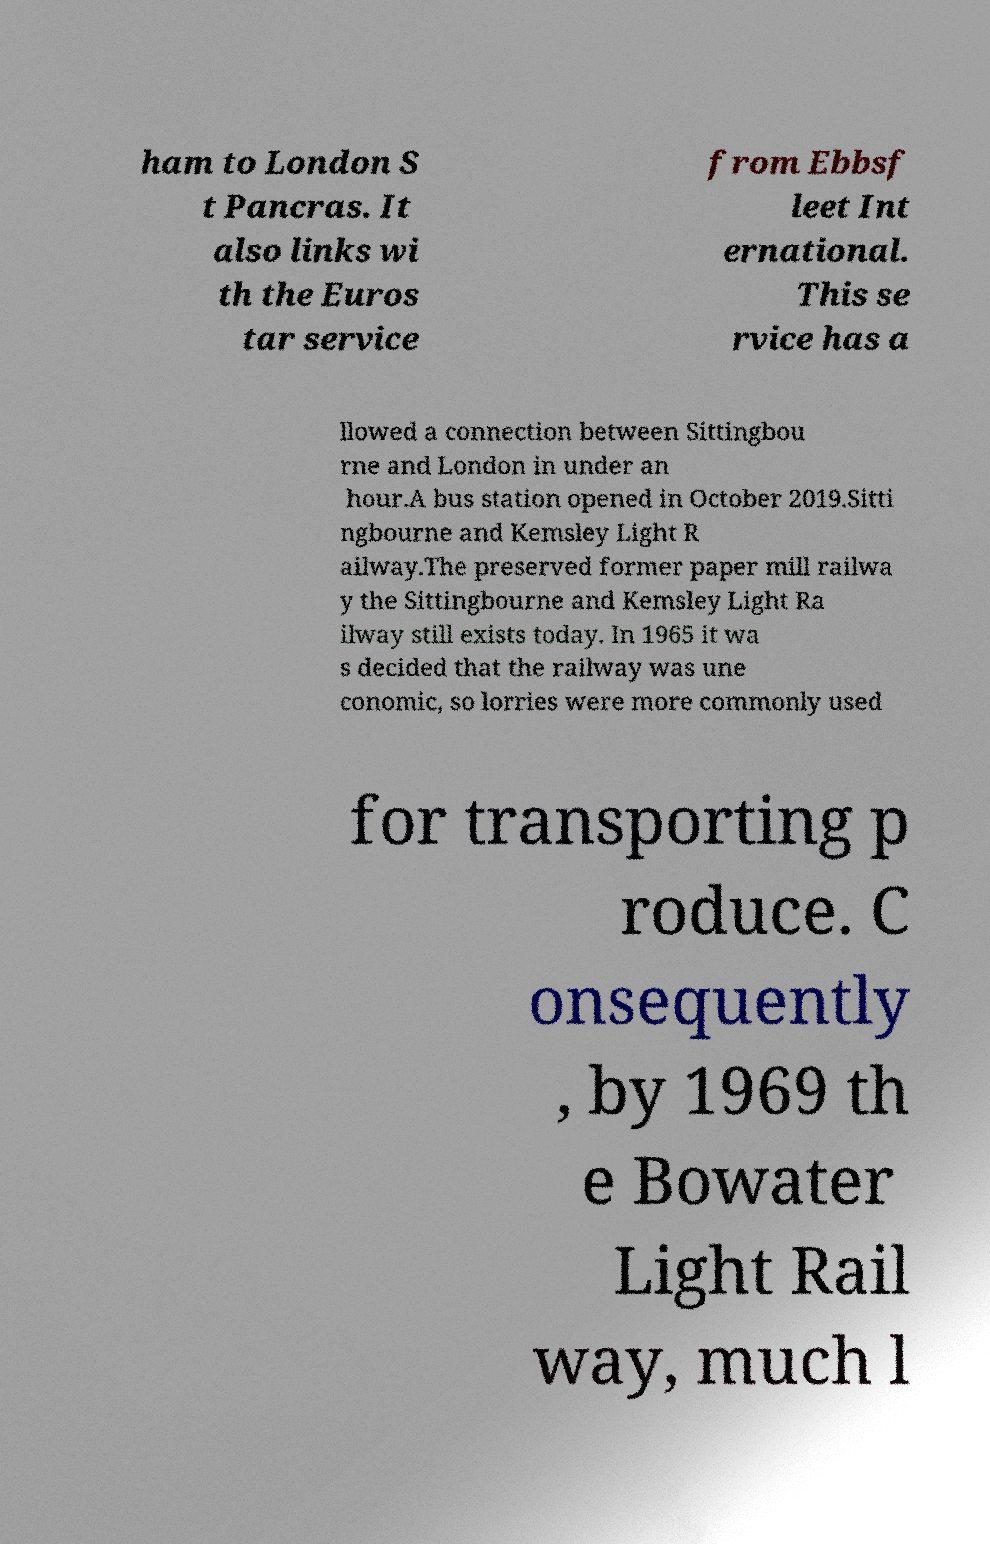For documentation purposes, I need the text within this image transcribed. Could you provide that? ham to London S t Pancras. It also links wi th the Euros tar service from Ebbsf leet Int ernational. This se rvice has a llowed a connection between Sittingbou rne and London in under an hour.A bus station opened in October 2019.Sitti ngbourne and Kemsley Light R ailway.The preserved former paper mill railwa y the Sittingbourne and Kemsley Light Ra ilway still exists today. In 1965 it wa s decided that the railway was une conomic, so lorries were more commonly used for transporting p roduce. C onsequently , by 1969 th e Bowater Light Rail way, much l 